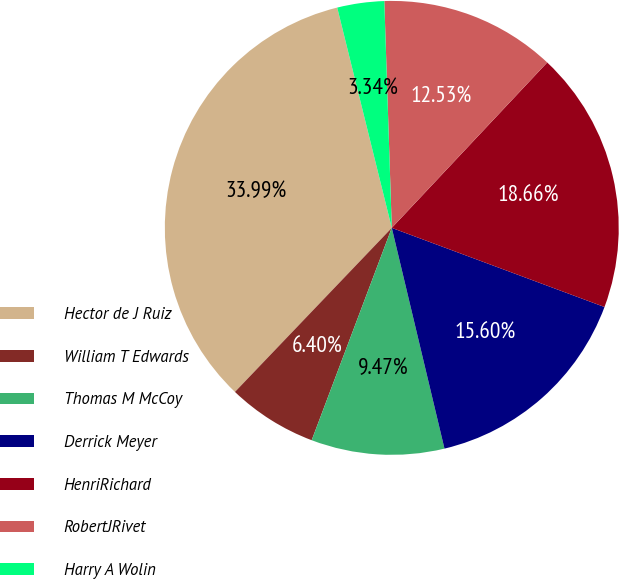<chart> <loc_0><loc_0><loc_500><loc_500><pie_chart><fcel>Hector de J Ruiz<fcel>William T Edwards<fcel>Thomas M McCoy<fcel>Derrick Meyer<fcel>HenriRichard<fcel>RobertJRivet<fcel>Harry A Wolin<nl><fcel>33.99%<fcel>6.4%<fcel>9.47%<fcel>15.6%<fcel>18.66%<fcel>12.53%<fcel>3.34%<nl></chart> 